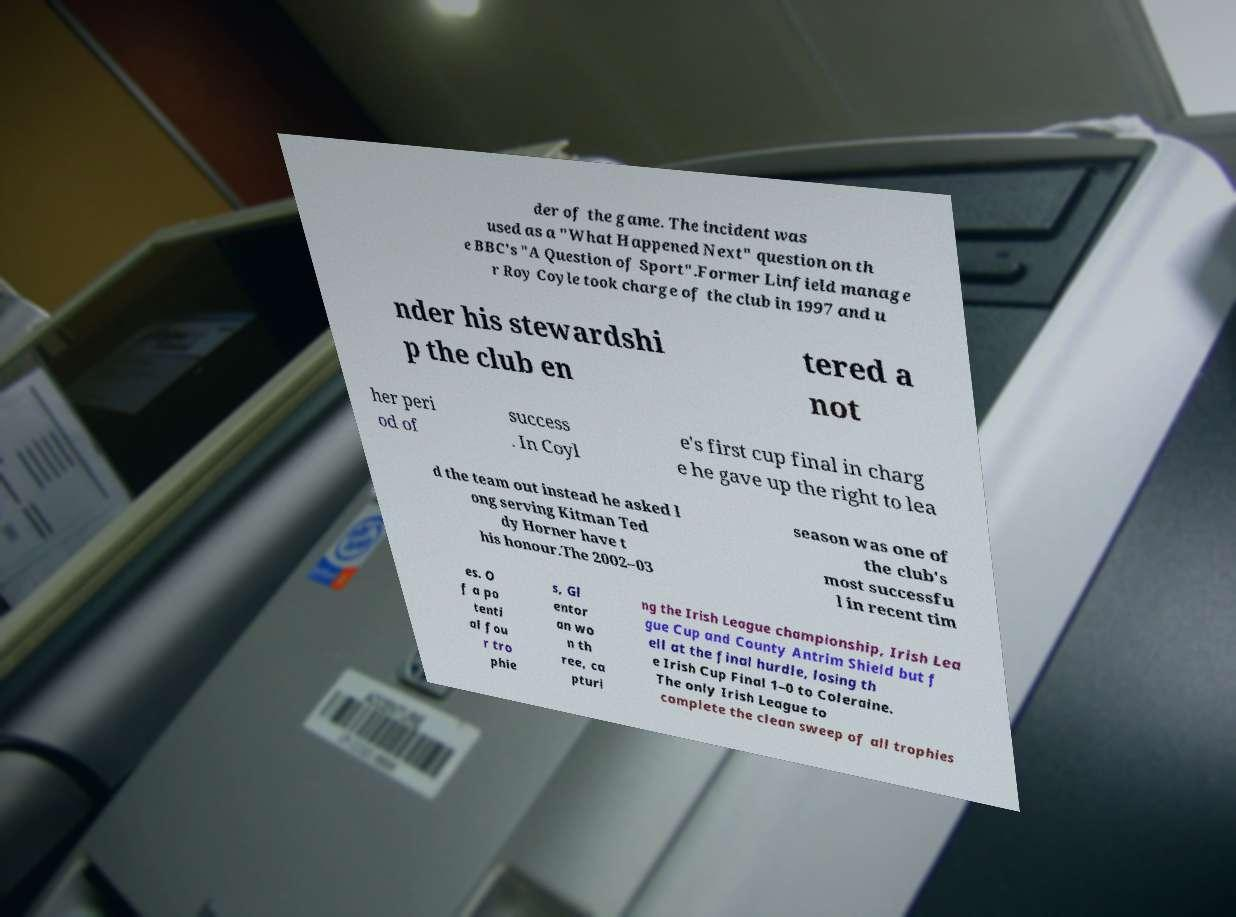I need the written content from this picture converted into text. Can you do that? der of the game. The incident was used as a "What Happened Next" question on th e BBC's "A Question of Sport".Former Linfield manage r Roy Coyle took charge of the club in 1997 and u nder his stewardshi p the club en tered a not her peri od of success . In Coyl e's first cup final in charg e he gave up the right to lea d the team out instead he asked l ong serving Kitman Ted dy Horner have t his honour.The 2002–03 season was one of the club's most successfu l in recent tim es. O f a po tenti al fou r tro phie s, Gl entor an wo n th ree, ca pturi ng the Irish League championship, Irish Lea gue Cup and County Antrim Shield but f ell at the final hurdle, losing th e Irish Cup Final 1–0 to Coleraine. The only Irish League to complete the clean sweep of all trophies 